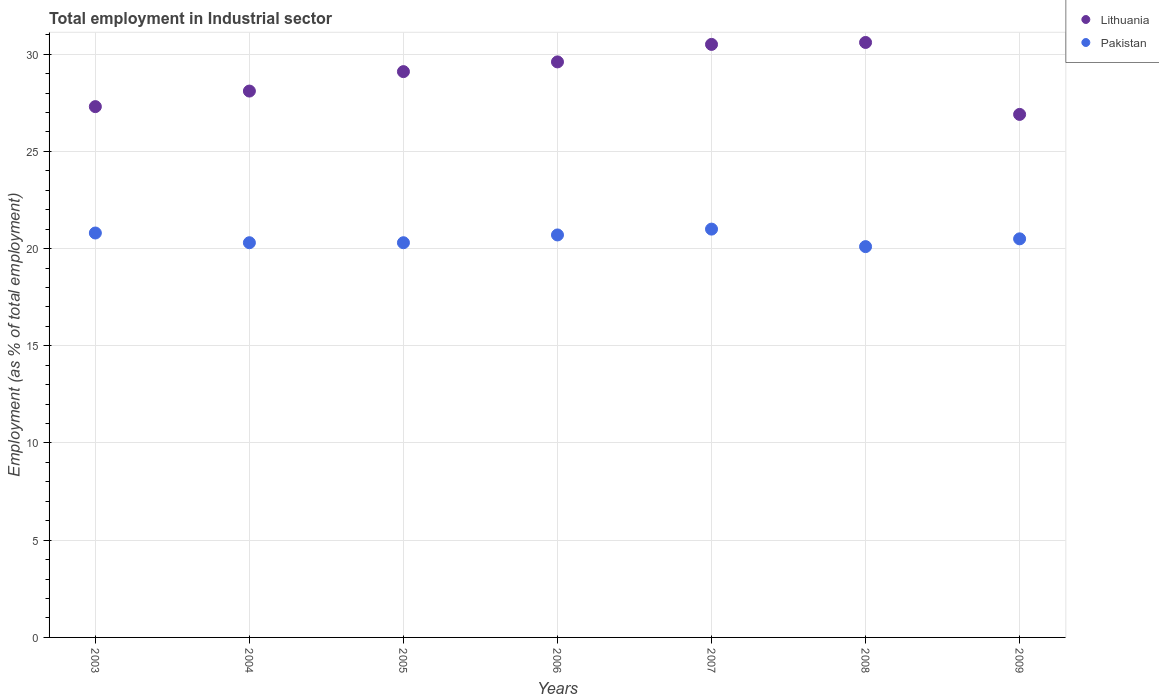How many different coloured dotlines are there?
Offer a very short reply. 2. Is the number of dotlines equal to the number of legend labels?
Provide a succinct answer. Yes. Across all years, what is the minimum employment in industrial sector in Pakistan?
Ensure brevity in your answer.  20.1. What is the total employment in industrial sector in Lithuania in the graph?
Provide a succinct answer. 202.1. What is the difference between the employment in industrial sector in Pakistan in 2003 and that in 2004?
Offer a very short reply. 0.5. What is the difference between the employment in industrial sector in Lithuania in 2006 and the employment in industrial sector in Pakistan in 2003?
Provide a succinct answer. 8.8. What is the average employment in industrial sector in Pakistan per year?
Offer a very short reply. 20.53. In the year 2006, what is the difference between the employment in industrial sector in Pakistan and employment in industrial sector in Lithuania?
Your answer should be compact. -8.9. What is the ratio of the employment in industrial sector in Pakistan in 2008 to that in 2009?
Give a very brief answer. 0.98. Is the difference between the employment in industrial sector in Pakistan in 2003 and 2008 greater than the difference between the employment in industrial sector in Lithuania in 2003 and 2008?
Ensure brevity in your answer.  Yes. What is the difference between the highest and the second highest employment in industrial sector in Lithuania?
Your answer should be compact. 0.1. What is the difference between the highest and the lowest employment in industrial sector in Pakistan?
Offer a very short reply. 0.9. Does the employment in industrial sector in Lithuania monotonically increase over the years?
Give a very brief answer. No. Is the employment in industrial sector in Pakistan strictly greater than the employment in industrial sector in Lithuania over the years?
Offer a terse response. No. How many years are there in the graph?
Your answer should be compact. 7. Are the values on the major ticks of Y-axis written in scientific E-notation?
Your answer should be very brief. No. Does the graph contain any zero values?
Provide a short and direct response. No. How many legend labels are there?
Your answer should be very brief. 2. What is the title of the graph?
Your response must be concise. Total employment in Industrial sector. Does "Guyana" appear as one of the legend labels in the graph?
Make the answer very short. No. What is the label or title of the Y-axis?
Your answer should be very brief. Employment (as % of total employment). What is the Employment (as % of total employment) in Lithuania in 2003?
Your answer should be compact. 27.3. What is the Employment (as % of total employment) of Pakistan in 2003?
Your answer should be compact. 20.8. What is the Employment (as % of total employment) of Lithuania in 2004?
Make the answer very short. 28.1. What is the Employment (as % of total employment) in Pakistan in 2004?
Offer a terse response. 20.3. What is the Employment (as % of total employment) of Lithuania in 2005?
Make the answer very short. 29.1. What is the Employment (as % of total employment) in Pakistan in 2005?
Your response must be concise. 20.3. What is the Employment (as % of total employment) in Lithuania in 2006?
Offer a terse response. 29.6. What is the Employment (as % of total employment) of Pakistan in 2006?
Make the answer very short. 20.7. What is the Employment (as % of total employment) of Lithuania in 2007?
Your answer should be very brief. 30.5. What is the Employment (as % of total employment) of Lithuania in 2008?
Provide a succinct answer. 30.6. What is the Employment (as % of total employment) of Pakistan in 2008?
Offer a terse response. 20.1. What is the Employment (as % of total employment) of Lithuania in 2009?
Your response must be concise. 26.9. What is the Employment (as % of total employment) in Pakistan in 2009?
Offer a terse response. 20.5. Across all years, what is the maximum Employment (as % of total employment) in Lithuania?
Make the answer very short. 30.6. Across all years, what is the minimum Employment (as % of total employment) of Lithuania?
Ensure brevity in your answer.  26.9. Across all years, what is the minimum Employment (as % of total employment) in Pakistan?
Offer a terse response. 20.1. What is the total Employment (as % of total employment) of Lithuania in the graph?
Your answer should be very brief. 202.1. What is the total Employment (as % of total employment) of Pakistan in the graph?
Make the answer very short. 143.7. What is the difference between the Employment (as % of total employment) in Lithuania in 2003 and that in 2005?
Provide a short and direct response. -1.8. What is the difference between the Employment (as % of total employment) of Lithuania in 2003 and that in 2006?
Give a very brief answer. -2.3. What is the difference between the Employment (as % of total employment) of Pakistan in 2003 and that in 2006?
Provide a short and direct response. 0.1. What is the difference between the Employment (as % of total employment) in Lithuania in 2003 and that in 2007?
Keep it short and to the point. -3.2. What is the difference between the Employment (as % of total employment) of Pakistan in 2003 and that in 2007?
Keep it short and to the point. -0.2. What is the difference between the Employment (as % of total employment) in Lithuania in 2003 and that in 2009?
Your answer should be compact. 0.4. What is the difference between the Employment (as % of total employment) in Pakistan in 2003 and that in 2009?
Give a very brief answer. 0.3. What is the difference between the Employment (as % of total employment) in Lithuania in 2004 and that in 2005?
Provide a succinct answer. -1. What is the difference between the Employment (as % of total employment) in Pakistan in 2004 and that in 2005?
Provide a succinct answer. 0. What is the difference between the Employment (as % of total employment) of Lithuania in 2004 and that in 2006?
Your answer should be very brief. -1.5. What is the difference between the Employment (as % of total employment) in Lithuania in 2004 and that in 2007?
Your answer should be compact. -2.4. What is the difference between the Employment (as % of total employment) in Pakistan in 2004 and that in 2007?
Provide a succinct answer. -0.7. What is the difference between the Employment (as % of total employment) in Lithuania in 2004 and that in 2008?
Ensure brevity in your answer.  -2.5. What is the difference between the Employment (as % of total employment) of Pakistan in 2004 and that in 2008?
Keep it short and to the point. 0.2. What is the difference between the Employment (as % of total employment) in Pakistan in 2004 and that in 2009?
Offer a very short reply. -0.2. What is the difference between the Employment (as % of total employment) of Lithuania in 2005 and that in 2008?
Ensure brevity in your answer.  -1.5. What is the difference between the Employment (as % of total employment) in Pakistan in 2005 and that in 2008?
Ensure brevity in your answer.  0.2. What is the difference between the Employment (as % of total employment) in Lithuania in 2005 and that in 2009?
Offer a very short reply. 2.2. What is the difference between the Employment (as % of total employment) in Lithuania in 2006 and that in 2008?
Your answer should be very brief. -1. What is the difference between the Employment (as % of total employment) in Lithuania in 2006 and that in 2009?
Offer a very short reply. 2.7. What is the difference between the Employment (as % of total employment) of Pakistan in 2007 and that in 2008?
Provide a short and direct response. 0.9. What is the difference between the Employment (as % of total employment) of Lithuania in 2007 and that in 2009?
Your response must be concise. 3.6. What is the difference between the Employment (as % of total employment) of Pakistan in 2007 and that in 2009?
Keep it short and to the point. 0.5. What is the difference between the Employment (as % of total employment) of Lithuania in 2003 and the Employment (as % of total employment) of Pakistan in 2004?
Make the answer very short. 7. What is the difference between the Employment (as % of total employment) in Lithuania in 2003 and the Employment (as % of total employment) in Pakistan in 2006?
Provide a short and direct response. 6.6. What is the difference between the Employment (as % of total employment) in Lithuania in 2003 and the Employment (as % of total employment) in Pakistan in 2007?
Ensure brevity in your answer.  6.3. What is the difference between the Employment (as % of total employment) in Lithuania in 2003 and the Employment (as % of total employment) in Pakistan in 2008?
Provide a succinct answer. 7.2. What is the difference between the Employment (as % of total employment) of Lithuania in 2004 and the Employment (as % of total employment) of Pakistan in 2005?
Offer a very short reply. 7.8. What is the difference between the Employment (as % of total employment) in Lithuania in 2004 and the Employment (as % of total employment) in Pakistan in 2006?
Your answer should be compact. 7.4. What is the difference between the Employment (as % of total employment) of Lithuania in 2004 and the Employment (as % of total employment) of Pakistan in 2008?
Your response must be concise. 8. What is the difference between the Employment (as % of total employment) of Lithuania in 2004 and the Employment (as % of total employment) of Pakistan in 2009?
Your answer should be very brief. 7.6. What is the difference between the Employment (as % of total employment) of Lithuania in 2005 and the Employment (as % of total employment) of Pakistan in 2006?
Ensure brevity in your answer.  8.4. What is the difference between the Employment (as % of total employment) in Lithuania in 2005 and the Employment (as % of total employment) in Pakistan in 2007?
Offer a very short reply. 8.1. What is the difference between the Employment (as % of total employment) in Lithuania in 2006 and the Employment (as % of total employment) in Pakistan in 2007?
Provide a short and direct response. 8.6. What is the difference between the Employment (as % of total employment) of Lithuania in 2008 and the Employment (as % of total employment) of Pakistan in 2009?
Offer a terse response. 10.1. What is the average Employment (as % of total employment) in Lithuania per year?
Your response must be concise. 28.87. What is the average Employment (as % of total employment) of Pakistan per year?
Provide a short and direct response. 20.53. In the year 2004, what is the difference between the Employment (as % of total employment) in Lithuania and Employment (as % of total employment) in Pakistan?
Offer a terse response. 7.8. In the year 2005, what is the difference between the Employment (as % of total employment) in Lithuania and Employment (as % of total employment) in Pakistan?
Offer a terse response. 8.8. In the year 2007, what is the difference between the Employment (as % of total employment) in Lithuania and Employment (as % of total employment) in Pakistan?
Offer a terse response. 9.5. What is the ratio of the Employment (as % of total employment) in Lithuania in 2003 to that in 2004?
Keep it short and to the point. 0.97. What is the ratio of the Employment (as % of total employment) of Pakistan in 2003 to that in 2004?
Your response must be concise. 1.02. What is the ratio of the Employment (as % of total employment) of Lithuania in 2003 to that in 2005?
Provide a short and direct response. 0.94. What is the ratio of the Employment (as % of total employment) in Pakistan in 2003 to that in 2005?
Your answer should be compact. 1.02. What is the ratio of the Employment (as % of total employment) in Lithuania in 2003 to that in 2006?
Your answer should be very brief. 0.92. What is the ratio of the Employment (as % of total employment) of Pakistan in 2003 to that in 2006?
Your answer should be very brief. 1. What is the ratio of the Employment (as % of total employment) of Lithuania in 2003 to that in 2007?
Provide a succinct answer. 0.9. What is the ratio of the Employment (as % of total employment) in Lithuania in 2003 to that in 2008?
Ensure brevity in your answer.  0.89. What is the ratio of the Employment (as % of total employment) of Pakistan in 2003 to that in 2008?
Make the answer very short. 1.03. What is the ratio of the Employment (as % of total employment) of Lithuania in 2003 to that in 2009?
Ensure brevity in your answer.  1.01. What is the ratio of the Employment (as % of total employment) in Pakistan in 2003 to that in 2009?
Offer a very short reply. 1.01. What is the ratio of the Employment (as % of total employment) of Lithuania in 2004 to that in 2005?
Provide a succinct answer. 0.97. What is the ratio of the Employment (as % of total employment) of Pakistan in 2004 to that in 2005?
Your answer should be very brief. 1. What is the ratio of the Employment (as % of total employment) in Lithuania in 2004 to that in 2006?
Offer a terse response. 0.95. What is the ratio of the Employment (as % of total employment) in Pakistan in 2004 to that in 2006?
Your answer should be very brief. 0.98. What is the ratio of the Employment (as % of total employment) in Lithuania in 2004 to that in 2007?
Make the answer very short. 0.92. What is the ratio of the Employment (as % of total employment) in Pakistan in 2004 to that in 2007?
Make the answer very short. 0.97. What is the ratio of the Employment (as % of total employment) of Lithuania in 2004 to that in 2008?
Ensure brevity in your answer.  0.92. What is the ratio of the Employment (as % of total employment) of Pakistan in 2004 to that in 2008?
Make the answer very short. 1.01. What is the ratio of the Employment (as % of total employment) in Lithuania in 2004 to that in 2009?
Your answer should be compact. 1.04. What is the ratio of the Employment (as % of total employment) of Pakistan in 2004 to that in 2009?
Make the answer very short. 0.99. What is the ratio of the Employment (as % of total employment) in Lithuania in 2005 to that in 2006?
Ensure brevity in your answer.  0.98. What is the ratio of the Employment (as % of total employment) in Pakistan in 2005 to that in 2006?
Offer a very short reply. 0.98. What is the ratio of the Employment (as % of total employment) of Lithuania in 2005 to that in 2007?
Keep it short and to the point. 0.95. What is the ratio of the Employment (as % of total employment) in Pakistan in 2005 to that in 2007?
Make the answer very short. 0.97. What is the ratio of the Employment (as % of total employment) of Lithuania in 2005 to that in 2008?
Provide a short and direct response. 0.95. What is the ratio of the Employment (as % of total employment) of Lithuania in 2005 to that in 2009?
Keep it short and to the point. 1.08. What is the ratio of the Employment (as % of total employment) of Pakistan in 2005 to that in 2009?
Your response must be concise. 0.99. What is the ratio of the Employment (as % of total employment) in Lithuania in 2006 to that in 2007?
Your answer should be compact. 0.97. What is the ratio of the Employment (as % of total employment) in Pakistan in 2006 to that in 2007?
Give a very brief answer. 0.99. What is the ratio of the Employment (as % of total employment) in Lithuania in 2006 to that in 2008?
Your answer should be very brief. 0.97. What is the ratio of the Employment (as % of total employment) in Pakistan in 2006 to that in 2008?
Provide a succinct answer. 1.03. What is the ratio of the Employment (as % of total employment) in Lithuania in 2006 to that in 2009?
Your answer should be very brief. 1.1. What is the ratio of the Employment (as % of total employment) in Pakistan in 2006 to that in 2009?
Give a very brief answer. 1.01. What is the ratio of the Employment (as % of total employment) in Lithuania in 2007 to that in 2008?
Your answer should be compact. 1. What is the ratio of the Employment (as % of total employment) in Pakistan in 2007 to that in 2008?
Provide a short and direct response. 1.04. What is the ratio of the Employment (as % of total employment) in Lithuania in 2007 to that in 2009?
Provide a short and direct response. 1.13. What is the ratio of the Employment (as % of total employment) of Pakistan in 2007 to that in 2009?
Give a very brief answer. 1.02. What is the ratio of the Employment (as % of total employment) in Lithuania in 2008 to that in 2009?
Provide a succinct answer. 1.14. What is the ratio of the Employment (as % of total employment) of Pakistan in 2008 to that in 2009?
Offer a terse response. 0.98. 